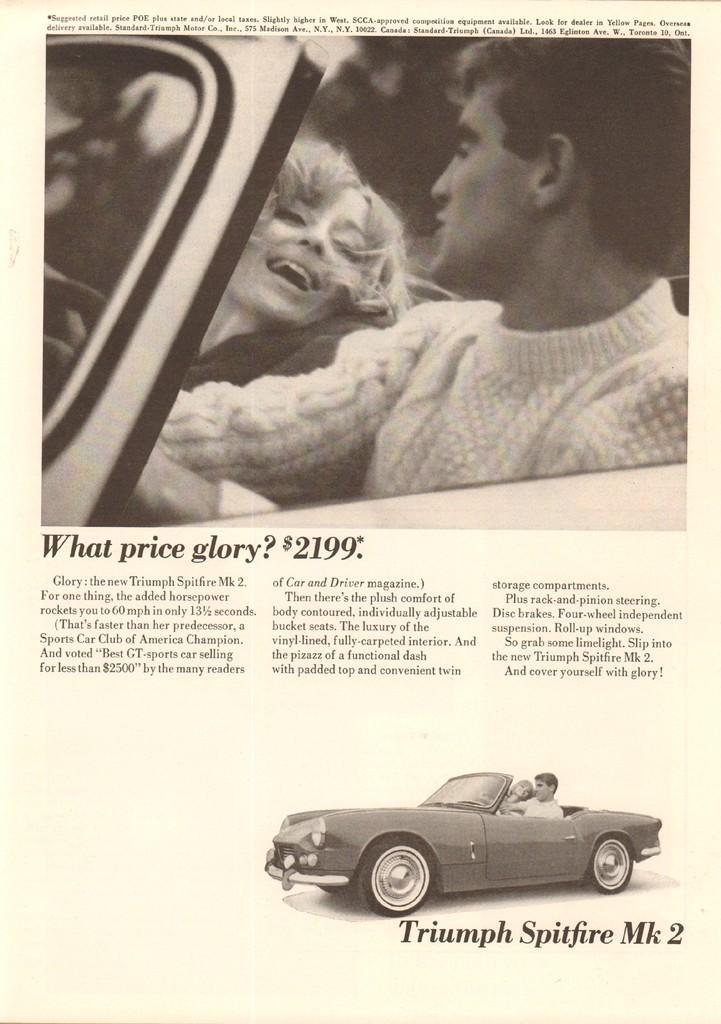In one or two sentences, can you explain what this image depicts? In this picture I can see a paper, there are words, numbers and images on the paper. 